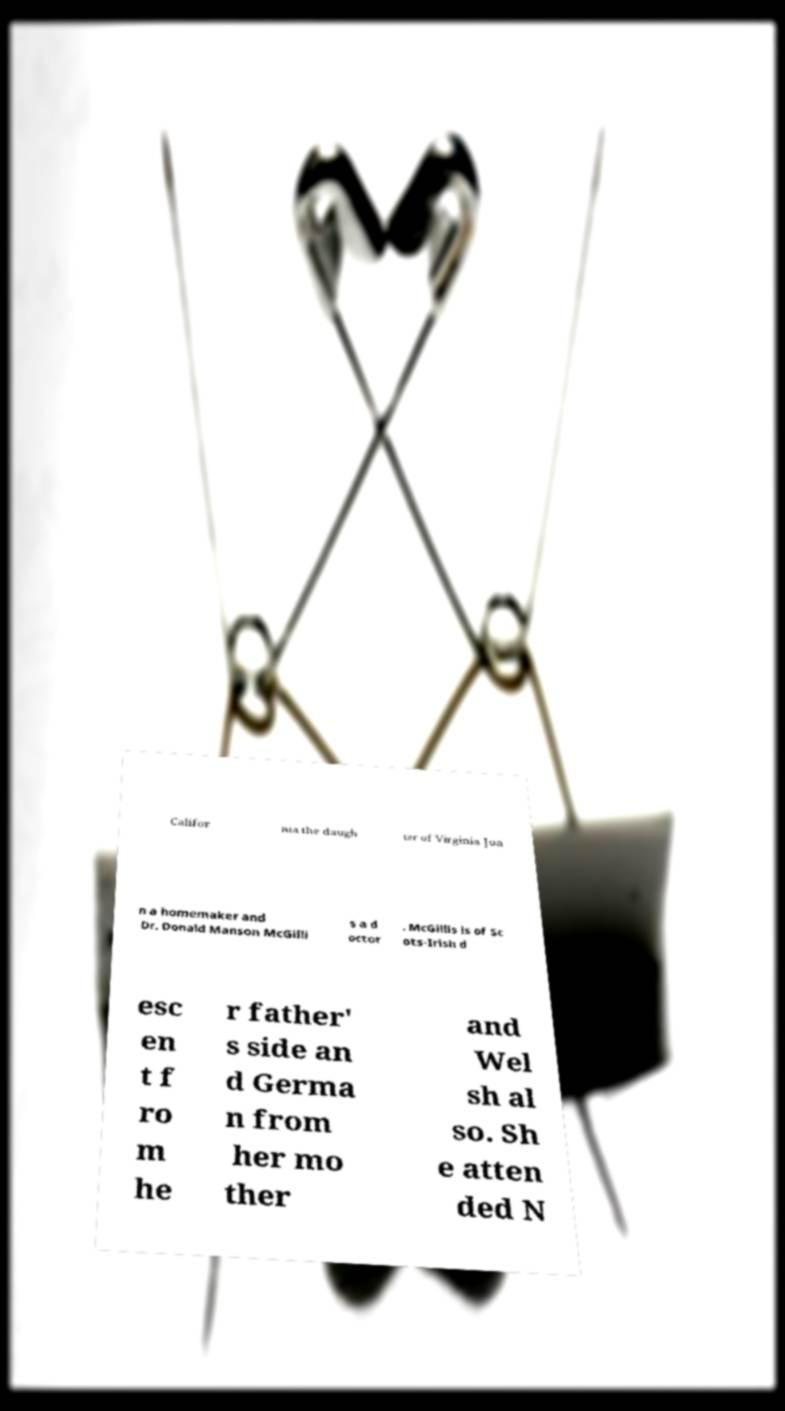Could you assist in decoding the text presented in this image and type it out clearly? Califor nia the daugh ter of Virginia Joa n a homemaker and Dr. Donald Manson McGilli s a d octor . McGillis is of Sc ots-Irish d esc en t f ro m he r father' s side an d Germa n from her mo ther and Wel sh al so. Sh e atten ded N 